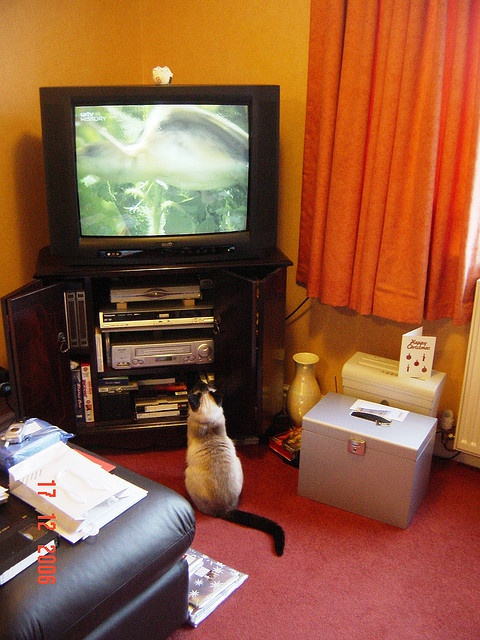Describe the objects in this image and their specific colors. I can see tv in orange, black, beige, darkgray, and lightgreen tones, tv in orange, black, beige, darkgray, and lightgreen tones, couch in orange, black, gray, and darkgray tones, cat in orange, black, brown, gray, and maroon tones, and book in orange, white, darkgray, and lavender tones in this image. 